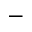<formula> <loc_0><loc_0><loc_500><loc_500>^ { - }</formula> 